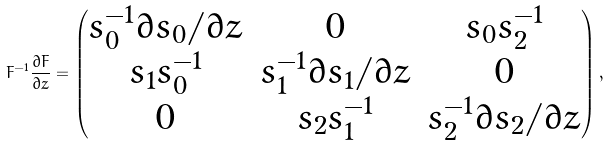<formula> <loc_0><loc_0><loc_500><loc_500>F ^ { - 1 } \frac { \partial F } { \partial z } = \begin{pmatrix} s _ { 0 } ^ { - 1 } \partial s _ { 0 } / \partial z & 0 & s _ { 0 } s _ { 2 } ^ { - 1 } \\ s _ { 1 } s _ { 0 } ^ { - 1 } & s _ { 1 } ^ { - 1 } \partial s _ { 1 } / \partial z & 0 \\ 0 & s _ { 2 } s _ { 1 } ^ { - 1 } & s _ { 2 } ^ { - 1 } \partial s _ { 2 } / \partial z \end{pmatrix} ,</formula> 